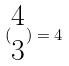<formula> <loc_0><loc_0><loc_500><loc_500>( \begin{matrix} 4 \\ 3 \end{matrix} ) = 4</formula> 